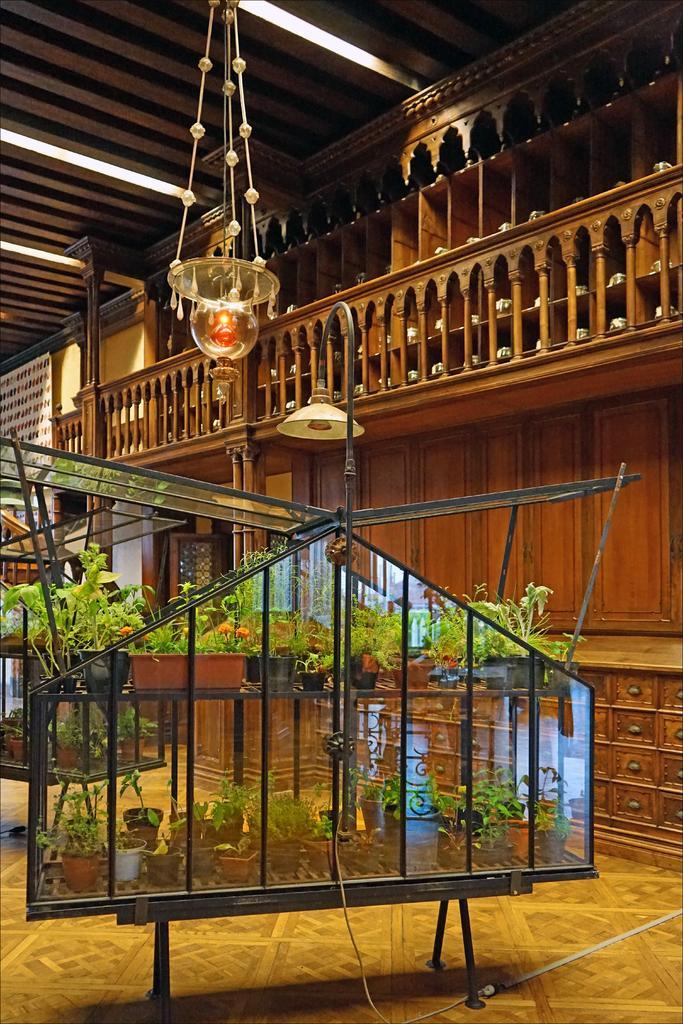Could you give a brief overview of what you see in this image? In this picture I can see the inside view of the building. At the bottom I can see some plants on the ports which are kept on this racks. At the top I can see the lights which are hanging from the roof. 